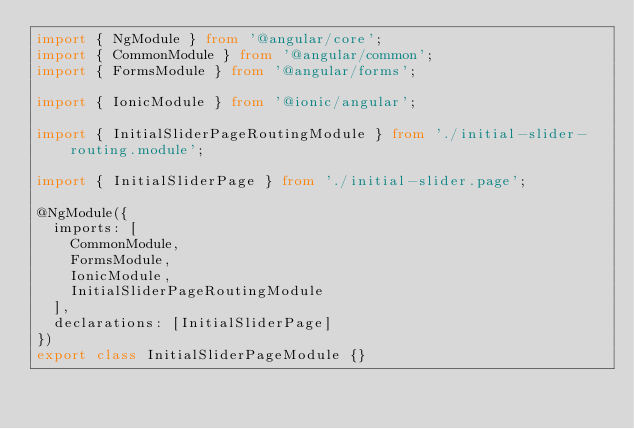Convert code to text. <code><loc_0><loc_0><loc_500><loc_500><_TypeScript_>import { NgModule } from '@angular/core';
import { CommonModule } from '@angular/common';
import { FormsModule } from '@angular/forms';

import { IonicModule } from '@ionic/angular';

import { InitialSliderPageRoutingModule } from './initial-slider-routing.module';

import { InitialSliderPage } from './initial-slider.page';

@NgModule({
  imports: [
    CommonModule,
    FormsModule,
    IonicModule,
    InitialSliderPageRoutingModule
  ],
  declarations: [InitialSliderPage]
})
export class InitialSliderPageModule {}
</code> 